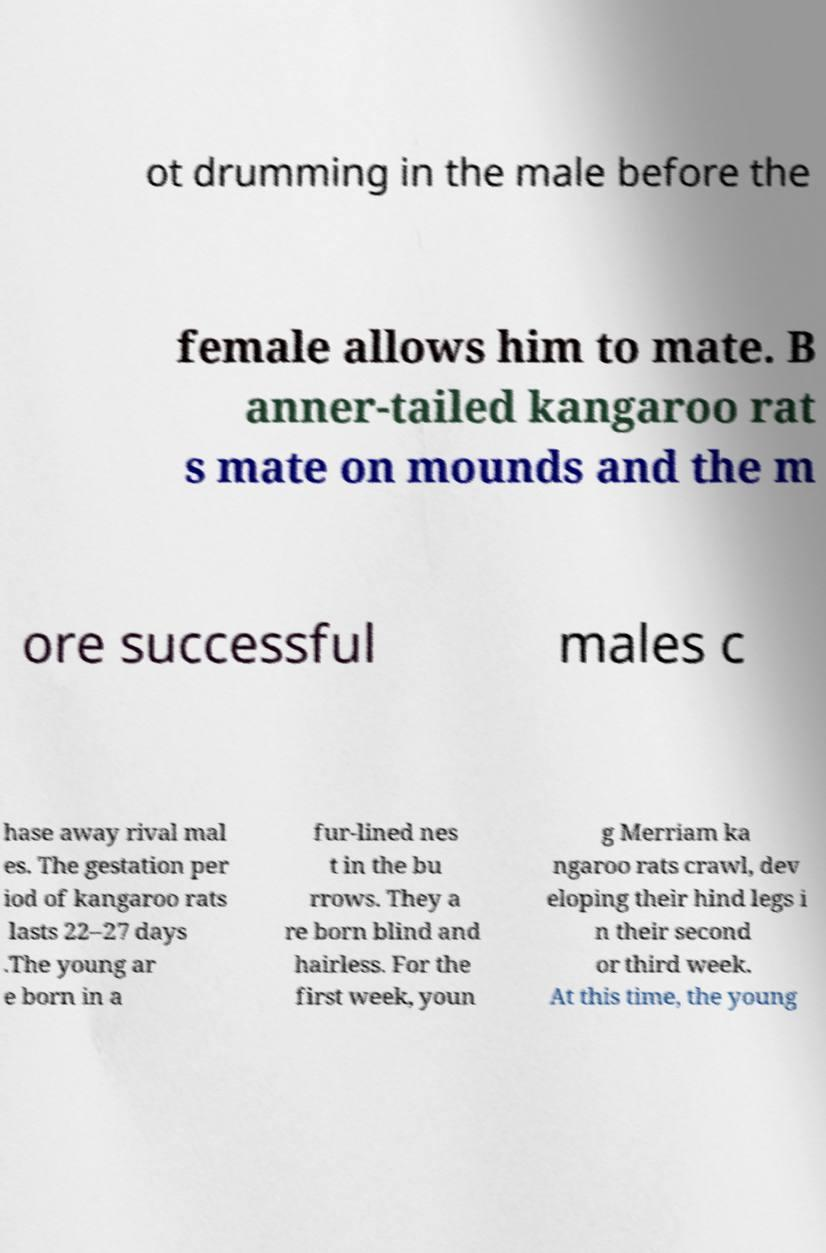Could you extract and type out the text from this image? ot drumming in the male before the female allows him to mate. B anner-tailed kangaroo rat s mate on mounds and the m ore successful males c hase away rival mal es. The gestation per iod of kangaroo rats lasts 22–27 days .The young ar e born in a fur-lined nes t in the bu rrows. They a re born blind and hairless. For the first week, youn g Merriam ka ngaroo rats crawl, dev eloping their hind legs i n their second or third week. At this time, the young 